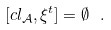Convert formula to latex. <formula><loc_0><loc_0><loc_500><loc_500>[ c l _ { \mathcal { A } } , \xi ^ { t } ] = \emptyset \ .</formula> 